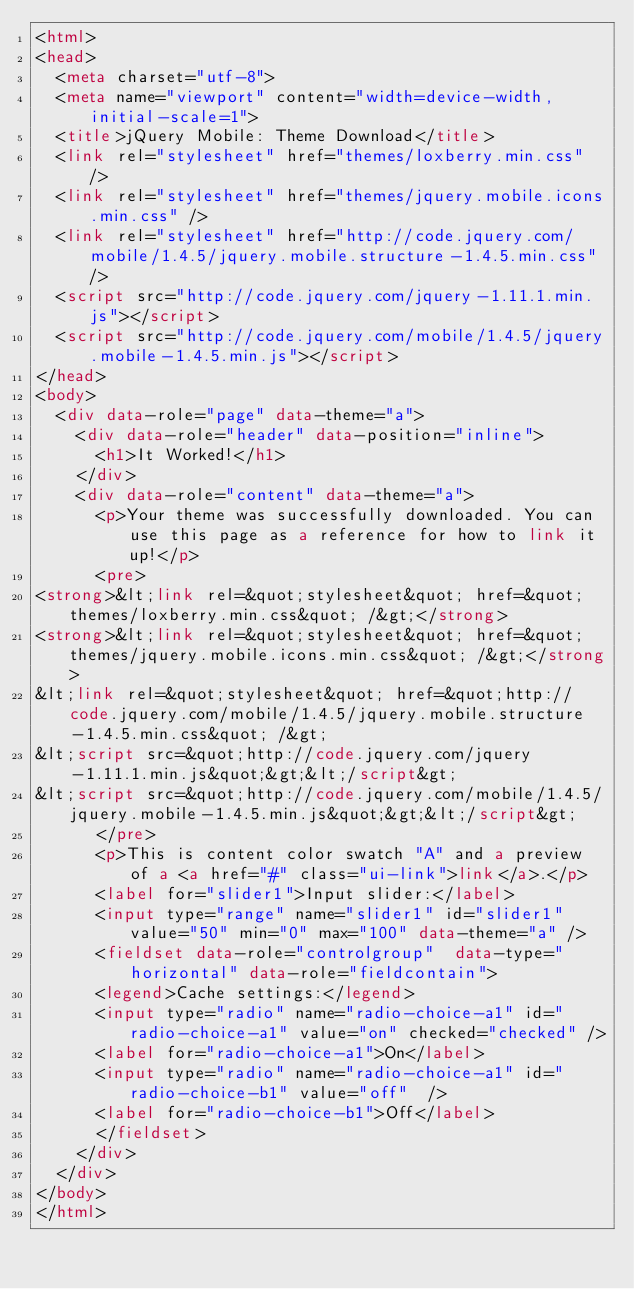<code> <loc_0><loc_0><loc_500><loc_500><_HTML_><html>
<head>
	<meta charset="utf-8">
	<meta name="viewport" content="width=device-width, initial-scale=1">
	<title>jQuery Mobile: Theme Download</title>
	<link rel="stylesheet" href="themes/loxberry.min.css" />
	<link rel="stylesheet" href="themes/jquery.mobile.icons.min.css" />
	<link rel="stylesheet" href="http://code.jquery.com/mobile/1.4.5/jquery.mobile.structure-1.4.5.min.css" />
	<script src="http://code.jquery.com/jquery-1.11.1.min.js"></script>
	<script src="http://code.jquery.com/mobile/1.4.5/jquery.mobile-1.4.5.min.js"></script>
</head>
<body>
	<div data-role="page" data-theme="a">
		<div data-role="header" data-position="inline">
			<h1>It Worked!</h1>
		</div>
		<div data-role="content" data-theme="a">
			<p>Your theme was successfully downloaded. You can use this page as a reference for how to link it up!</p>
			<pre>
<strong>&lt;link rel=&quot;stylesheet&quot; href=&quot;themes/loxberry.min.css&quot; /&gt;</strong>
<strong>&lt;link rel=&quot;stylesheet&quot; href=&quot;themes/jquery.mobile.icons.min.css&quot; /&gt;</strong>
&lt;link rel=&quot;stylesheet&quot; href=&quot;http://code.jquery.com/mobile/1.4.5/jquery.mobile.structure-1.4.5.min.css&quot; /&gt;
&lt;script src=&quot;http://code.jquery.com/jquery-1.11.1.min.js&quot;&gt;&lt;/script&gt;
&lt;script src=&quot;http://code.jquery.com/mobile/1.4.5/jquery.mobile-1.4.5.min.js&quot;&gt;&lt;/script&gt;
			</pre>
			<p>This is content color swatch "A" and a preview of a <a href="#" class="ui-link">link</a>.</p>
			<label for="slider1">Input slider:</label>
			<input type="range" name="slider1" id="slider1" value="50" min="0" max="100" data-theme="a" />
			<fieldset data-role="controlgroup"  data-type="horizontal" data-role="fieldcontain">
			<legend>Cache settings:</legend>
			<input type="radio" name="radio-choice-a1" id="radio-choice-a1" value="on" checked="checked" />
			<label for="radio-choice-a1">On</label>
			<input type="radio" name="radio-choice-a1" id="radio-choice-b1" value="off"  />
			<label for="radio-choice-b1">Off</label>
			</fieldset>
		</div>
	</div>
</body>
</html></code> 